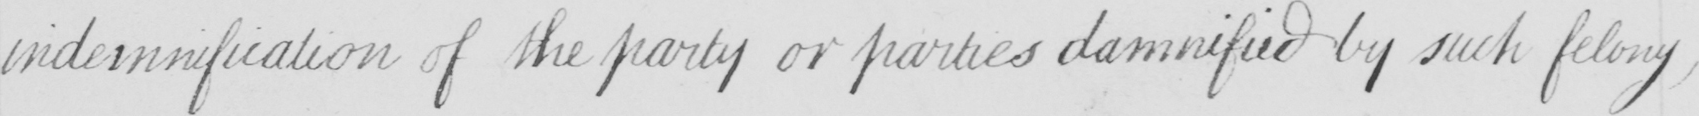Can you tell me what this handwritten text says? indemnification of the party or parties damnified by such felony , 